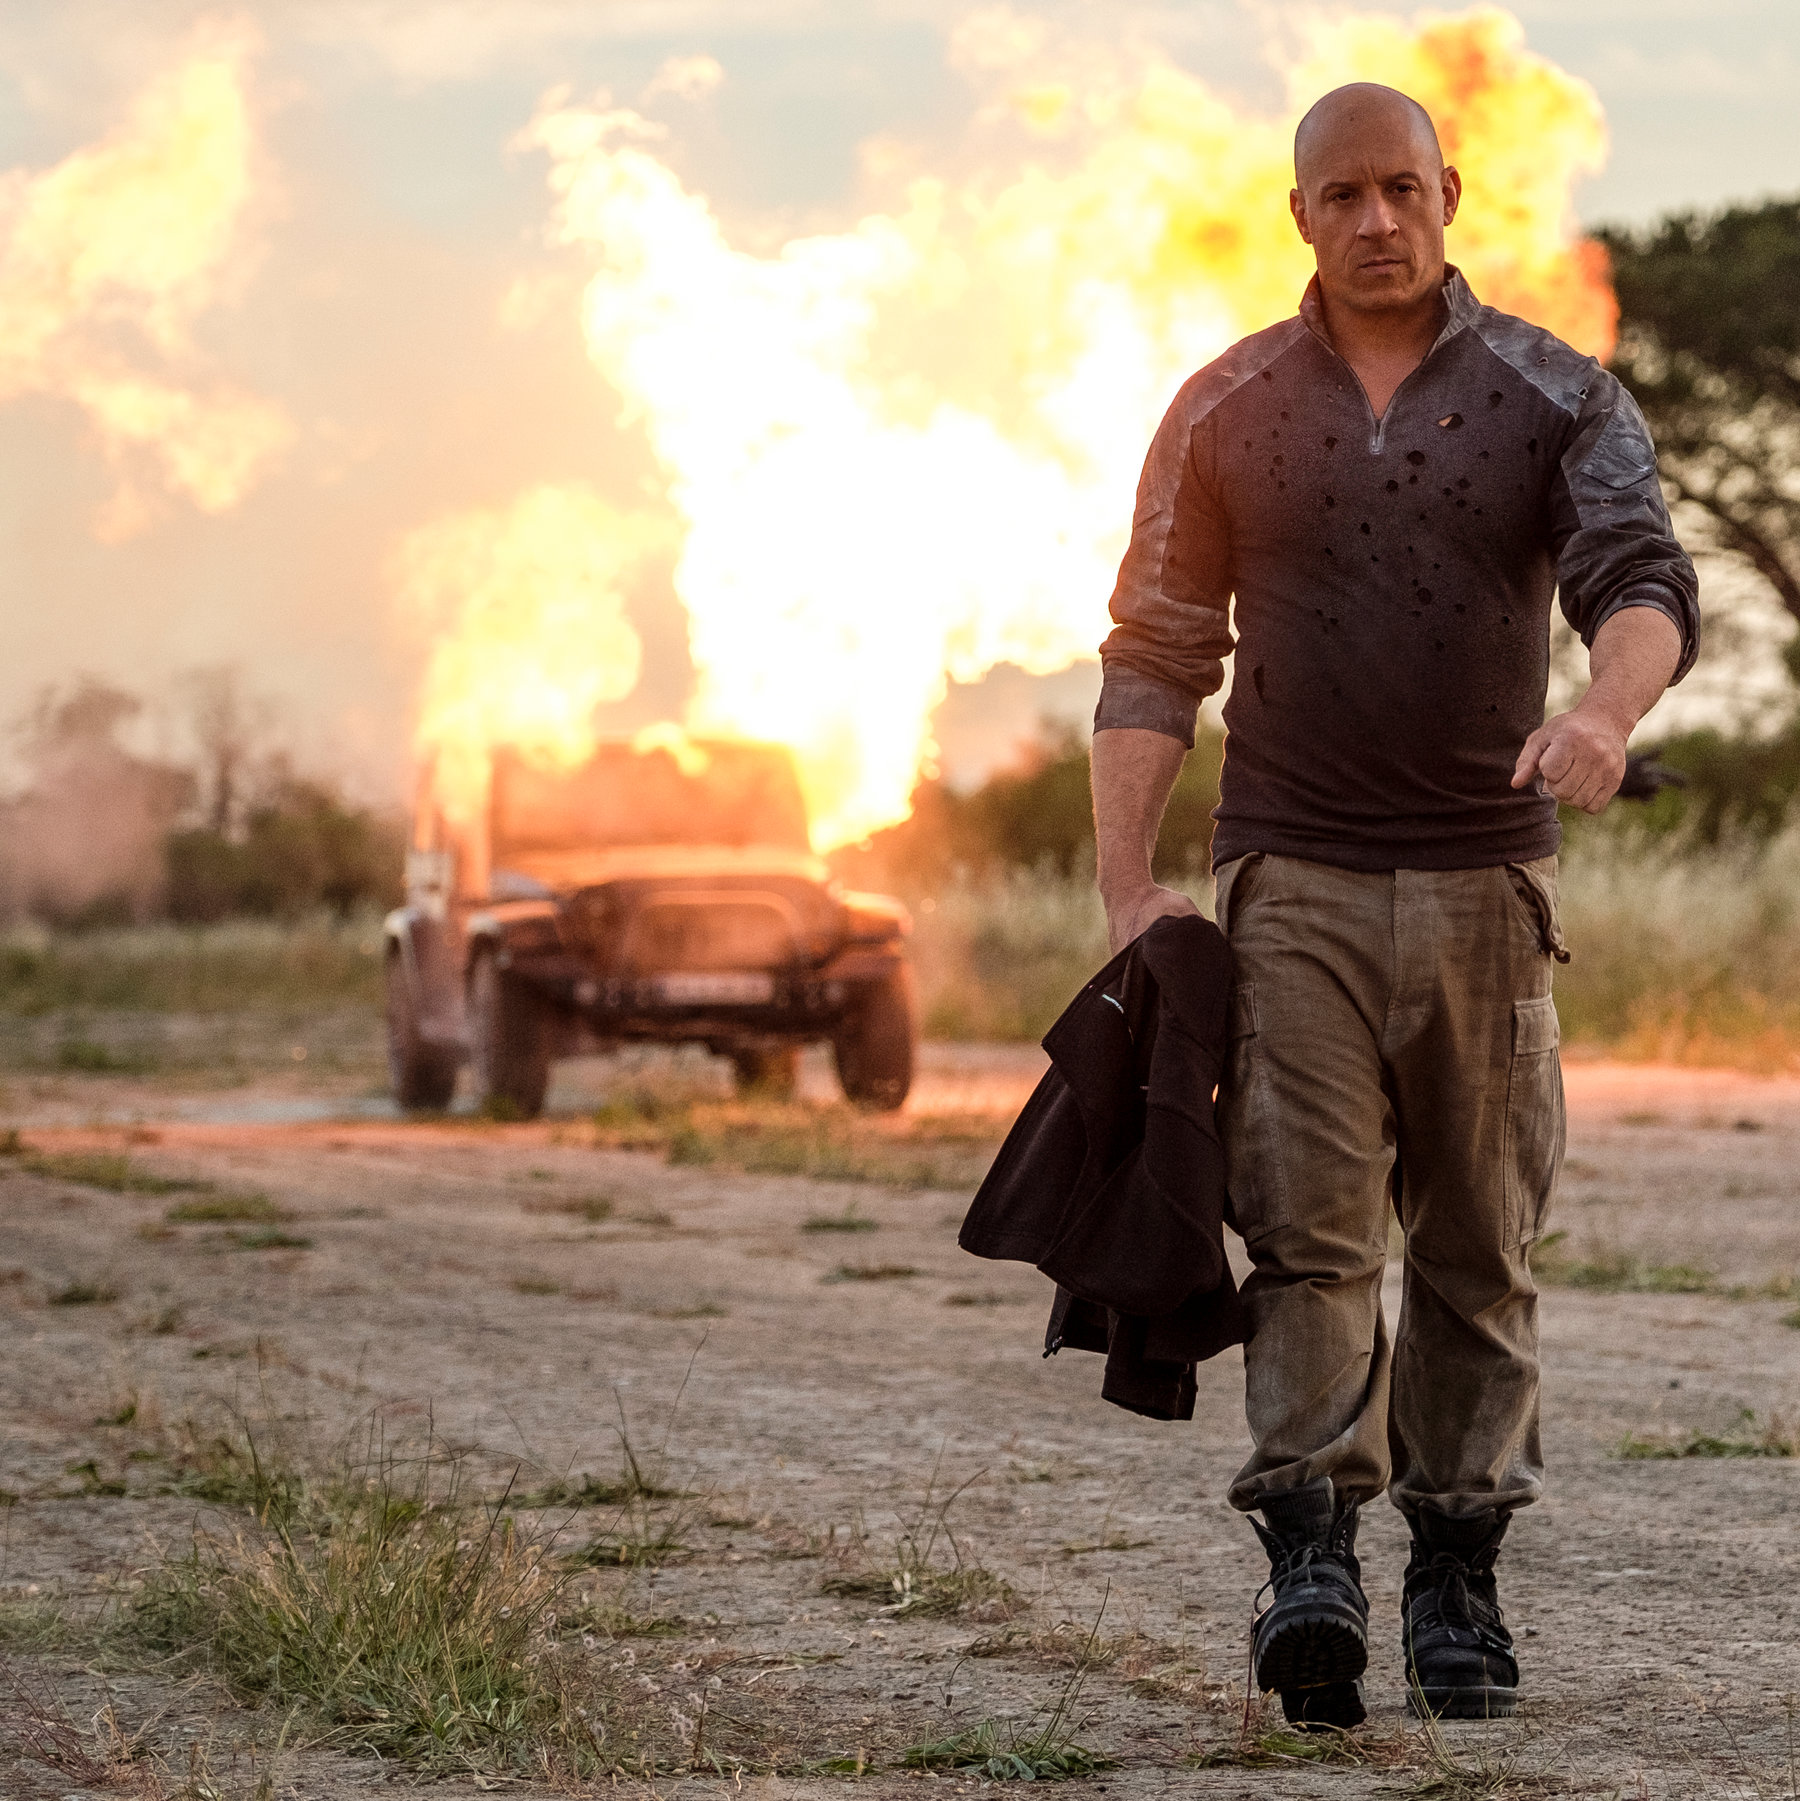How does the expression and posture of the man contribute to the overall mood of the image? The man's composed expression and casual posture, walking steadily away from the explosion, add a layer of dramatic irony to the image. His nonchalant demeanor in contrast with the chaotic and fiery background intensifies the scene's dramatic effect, embodying a stoic or fearless persona. 